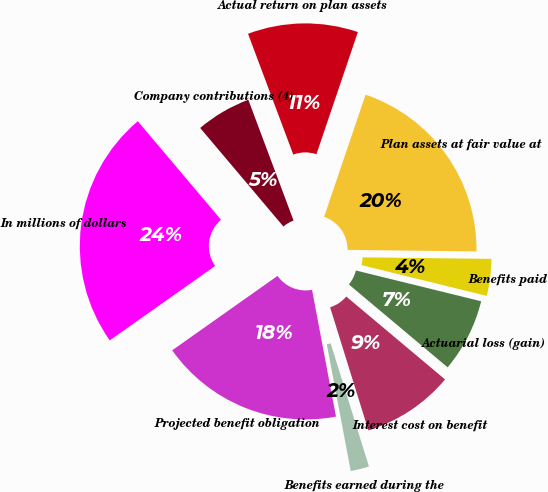Convert chart. <chart><loc_0><loc_0><loc_500><loc_500><pie_chart><fcel>In millions of dollars<fcel>Projected benefit obligation<fcel>Benefits earned during the<fcel>Interest cost on benefit<fcel>Actuarial loss (gain)<fcel>Benefits paid<fcel>Plan assets at fair value at<fcel>Actual return on plan assets<fcel>Company contributions (4)<nl><fcel>23.63%<fcel>18.18%<fcel>1.83%<fcel>9.09%<fcel>7.28%<fcel>3.64%<fcel>19.99%<fcel>10.91%<fcel>5.46%<nl></chart> 